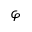Convert formula to latex. <formula><loc_0><loc_0><loc_500><loc_500>\varphi</formula> 